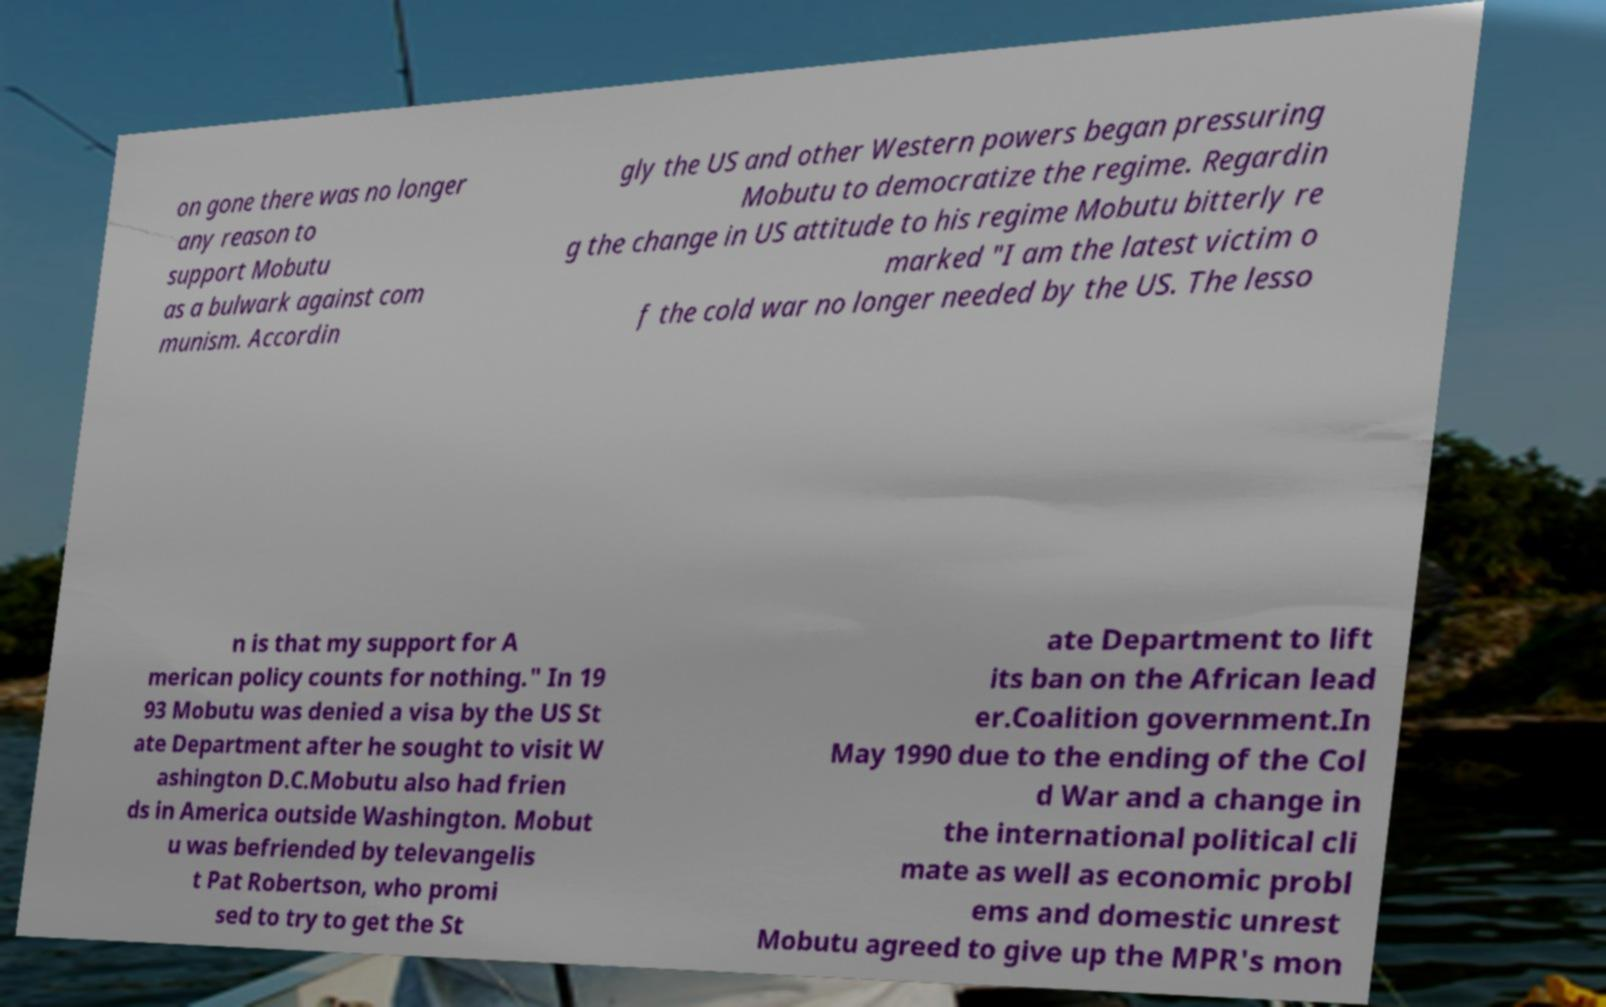What messages or text are displayed in this image? I need them in a readable, typed format. on gone there was no longer any reason to support Mobutu as a bulwark against com munism. Accordin gly the US and other Western powers began pressuring Mobutu to democratize the regime. Regardin g the change in US attitude to his regime Mobutu bitterly re marked "I am the latest victim o f the cold war no longer needed by the US. The lesso n is that my support for A merican policy counts for nothing." In 19 93 Mobutu was denied a visa by the US St ate Department after he sought to visit W ashington D.C.Mobutu also had frien ds in America outside Washington. Mobut u was befriended by televangelis t Pat Robertson, who promi sed to try to get the St ate Department to lift its ban on the African lead er.Coalition government.In May 1990 due to the ending of the Col d War and a change in the international political cli mate as well as economic probl ems and domestic unrest Mobutu agreed to give up the MPR's mon 